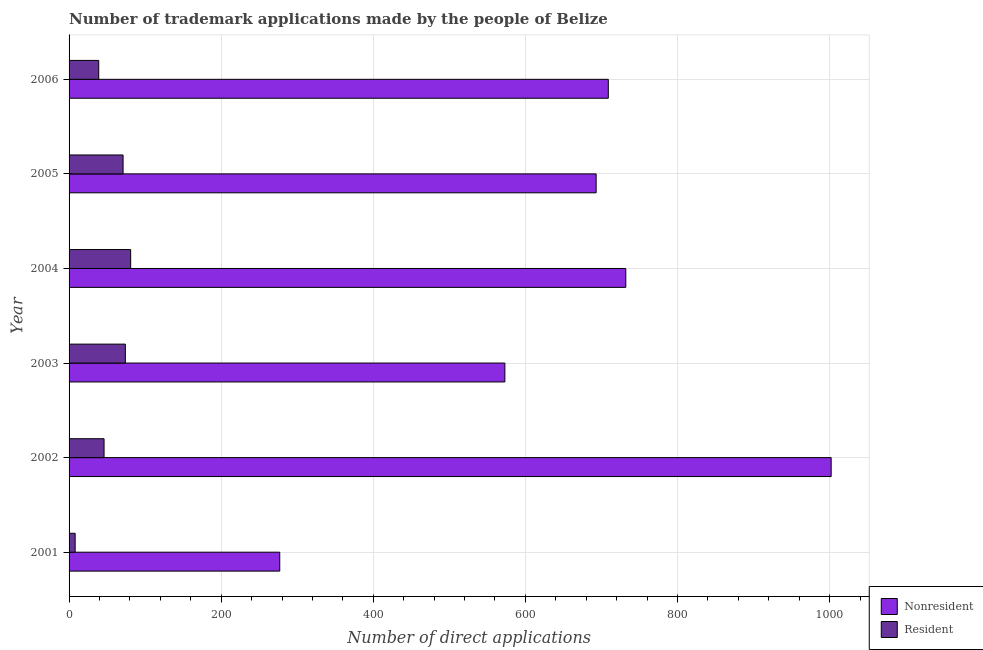How many different coloured bars are there?
Ensure brevity in your answer.  2. Are the number of bars per tick equal to the number of legend labels?
Provide a short and direct response. Yes. How many bars are there on the 1st tick from the bottom?
Your response must be concise. 2. What is the label of the 1st group of bars from the top?
Ensure brevity in your answer.  2006. What is the number of trademark applications made by residents in 2003?
Make the answer very short. 74. Across all years, what is the maximum number of trademark applications made by residents?
Offer a terse response. 81. Across all years, what is the minimum number of trademark applications made by non residents?
Make the answer very short. 277. In which year was the number of trademark applications made by residents minimum?
Keep it short and to the point. 2001. What is the total number of trademark applications made by non residents in the graph?
Ensure brevity in your answer.  3986. What is the difference between the number of trademark applications made by residents in 2003 and that in 2005?
Keep it short and to the point. 3. What is the difference between the number of trademark applications made by residents in 2006 and the number of trademark applications made by non residents in 2004?
Your response must be concise. -693. What is the average number of trademark applications made by residents per year?
Provide a short and direct response. 53.17. In the year 2006, what is the difference between the number of trademark applications made by non residents and number of trademark applications made by residents?
Your answer should be compact. 670. In how many years, is the number of trademark applications made by residents greater than 520 ?
Ensure brevity in your answer.  0. What is the ratio of the number of trademark applications made by residents in 2001 to that in 2002?
Offer a terse response. 0.17. What is the difference between the highest and the lowest number of trademark applications made by residents?
Your answer should be very brief. 73. Is the sum of the number of trademark applications made by residents in 2001 and 2004 greater than the maximum number of trademark applications made by non residents across all years?
Keep it short and to the point. No. What does the 2nd bar from the top in 2002 represents?
Make the answer very short. Nonresident. What does the 2nd bar from the bottom in 2001 represents?
Provide a short and direct response. Resident. How many bars are there?
Offer a terse response. 12. Are all the bars in the graph horizontal?
Give a very brief answer. Yes. Are the values on the major ticks of X-axis written in scientific E-notation?
Offer a very short reply. No. Where does the legend appear in the graph?
Keep it short and to the point. Bottom right. How many legend labels are there?
Your answer should be compact. 2. How are the legend labels stacked?
Your response must be concise. Vertical. What is the title of the graph?
Give a very brief answer. Number of trademark applications made by the people of Belize. What is the label or title of the X-axis?
Offer a very short reply. Number of direct applications. What is the label or title of the Y-axis?
Ensure brevity in your answer.  Year. What is the Number of direct applications in Nonresident in 2001?
Provide a succinct answer. 277. What is the Number of direct applications in Resident in 2001?
Your response must be concise. 8. What is the Number of direct applications in Nonresident in 2002?
Offer a terse response. 1002. What is the Number of direct applications of Nonresident in 2003?
Offer a terse response. 573. What is the Number of direct applications of Nonresident in 2004?
Your response must be concise. 732. What is the Number of direct applications in Nonresident in 2005?
Provide a short and direct response. 693. What is the Number of direct applications in Nonresident in 2006?
Your answer should be compact. 709. Across all years, what is the maximum Number of direct applications in Nonresident?
Offer a very short reply. 1002. Across all years, what is the maximum Number of direct applications in Resident?
Your response must be concise. 81. Across all years, what is the minimum Number of direct applications in Nonresident?
Offer a very short reply. 277. Across all years, what is the minimum Number of direct applications in Resident?
Your answer should be very brief. 8. What is the total Number of direct applications of Nonresident in the graph?
Keep it short and to the point. 3986. What is the total Number of direct applications in Resident in the graph?
Provide a short and direct response. 319. What is the difference between the Number of direct applications of Nonresident in 2001 and that in 2002?
Make the answer very short. -725. What is the difference between the Number of direct applications of Resident in 2001 and that in 2002?
Your response must be concise. -38. What is the difference between the Number of direct applications of Nonresident in 2001 and that in 2003?
Provide a succinct answer. -296. What is the difference between the Number of direct applications of Resident in 2001 and that in 2003?
Make the answer very short. -66. What is the difference between the Number of direct applications in Nonresident in 2001 and that in 2004?
Your answer should be compact. -455. What is the difference between the Number of direct applications of Resident in 2001 and that in 2004?
Give a very brief answer. -73. What is the difference between the Number of direct applications of Nonresident in 2001 and that in 2005?
Your response must be concise. -416. What is the difference between the Number of direct applications in Resident in 2001 and that in 2005?
Your answer should be compact. -63. What is the difference between the Number of direct applications in Nonresident in 2001 and that in 2006?
Provide a short and direct response. -432. What is the difference between the Number of direct applications in Resident in 2001 and that in 2006?
Keep it short and to the point. -31. What is the difference between the Number of direct applications of Nonresident in 2002 and that in 2003?
Your answer should be compact. 429. What is the difference between the Number of direct applications of Resident in 2002 and that in 2003?
Offer a very short reply. -28. What is the difference between the Number of direct applications of Nonresident in 2002 and that in 2004?
Make the answer very short. 270. What is the difference between the Number of direct applications of Resident in 2002 and that in 2004?
Provide a succinct answer. -35. What is the difference between the Number of direct applications of Nonresident in 2002 and that in 2005?
Offer a very short reply. 309. What is the difference between the Number of direct applications in Resident in 2002 and that in 2005?
Your response must be concise. -25. What is the difference between the Number of direct applications in Nonresident in 2002 and that in 2006?
Provide a succinct answer. 293. What is the difference between the Number of direct applications in Nonresident in 2003 and that in 2004?
Offer a very short reply. -159. What is the difference between the Number of direct applications in Resident in 2003 and that in 2004?
Ensure brevity in your answer.  -7. What is the difference between the Number of direct applications of Nonresident in 2003 and that in 2005?
Provide a succinct answer. -120. What is the difference between the Number of direct applications in Nonresident in 2003 and that in 2006?
Ensure brevity in your answer.  -136. What is the difference between the Number of direct applications of Resident in 2003 and that in 2006?
Your answer should be compact. 35. What is the difference between the Number of direct applications of Resident in 2004 and that in 2005?
Provide a succinct answer. 10. What is the difference between the Number of direct applications in Nonresident in 2004 and that in 2006?
Your answer should be very brief. 23. What is the difference between the Number of direct applications of Nonresident in 2005 and that in 2006?
Give a very brief answer. -16. What is the difference between the Number of direct applications of Resident in 2005 and that in 2006?
Offer a terse response. 32. What is the difference between the Number of direct applications of Nonresident in 2001 and the Number of direct applications of Resident in 2002?
Ensure brevity in your answer.  231. What is the difference between the Number of direct applications in Nonresident in 2001 and the Number of direct applications in Resident in 2003?
Your answer should be very brief. 203. What is the difference between the Number of direct applications in Nonresident in 2001 and the Number of direct applications in Resident in 2004?
Keep it short and to the point. 196. What is the difference between the Number of direct applications of Nonresident in 2001 and the Number of direct applications of Resident in 2005?
Offer a terse response. 206. What is the difference between the Number of direct applications in Nonresident in 2001 and the Number of direct applications in Resident in 2006?
Ensure brevity in your answer.  238. What is the difference between the Number of direct applications of Nonresident in 2002 and the Number of direct applications of Resident in 2003?
Offer a very short reply. 928. What is the difference between the Number of direct applications of Nonresident in 2002 and the Number of direct applications of Resident in 2004?
Keep it short and to the point. 921. What is the difference between the Number of direct applications of Nonresident in 2002 and the Number of direct applications of Resident in 2005?
Your answer should be compact. 931. What is the difference between the Number of direct applications in Nonresident in 2002 and the Number of direct applications in Resident in 2006?
Your answer should be compact. 963. What is the difference between the Number of direct applications of Nonresident in 2003 and the Number of direct applications of Resident in 2004?
Provide a short and direct response. 492. What is the difference between the Number of direct applications of Nonresident in 2003 and the Number of direct applications of Resident in 2005?
Offer a terse response. 502. What is the difference between the Number of direct applications of Nonresident in 2003 and the Number of direct applications of Resident in 2006?
Ensure brevity in your answer.  534. What is the difference between the Number of direct applications of Nonresident in 2004 and the Number of direct applications of Resident in 2005?
Your response must be concise. 661. What is the difference between the Number of direct applications in Nonresident in 2004 and the Number of direct applications in Resident in 2006?
Ensure brevity in your answer.  693. What is the difference between the Number of direct applications in Nonresident in 2005 and the Number of direct applications in Resident in 2006?
Your answer should be compact. 654. What is the average Number of direct applications in Nonresident per year?
Give a very brief answer. 664.33. What is the average Number of direct applications of Resident per year?
Your answer should be very brief. 53.17. In the year 2001, what is the difference between the Number of direct applications in Nonresident and Number of direct applications in Resident?
Make the answer very short. 269. In the year 2002, what is the difference between the Number of direct applications in Nonresident and Number of direct applications in Resident?
Your answer should be very brief. 956. In the year 2003, what is the difference between the Number of direct applications in Nonresident and Number of direct applications in Resident?
Offer a terse response. 499. In the year 2004, what is the difference between the Number of direct applications of Nonresident and Number of direct applications of Resident?
Make the answer very short. 651. In the year 2005, what is the difference between the Number of direct applications in Nonresident and Number of direct applications in Resident?
Your answer should be compact. 622. In the year 2006, what is the difference between the Number of direct applications in Nonresident and Number of direct applications in Resident?
Make the answer very short. 670. What is the ratio of the Number of direct applications of Nonresident in 2001 to that in 2002?
Offer a terse response. 0.28. What is the ratio of the Number of direct applications of Resident in 2001 to that in 2002?
Your answer should be compact. 0.17. What is the ratio of the Number of direct applications in Nonresident in 2001 to that in 2003?
Provide a short and direct response. 0.48. What is the ratio of the Number of direct applications of Resident in 2001 to that in 2003?
Make the answer very short. 0.11. What is the ratio of the Number of direct applications of Nonresident in 2001 to that in 2004?
Your answer should be compact. 0.38. What is the ratio of the Number of direct applications of Resident in 2001 to that in 2004?
Offer a very short reply. 0.1. What is the ratio of the Number of direct applications of Nonresident in 2001 to that in 2005?
Give a very brief answer. 0.4. What is the ratio of the Number of direct applications in Resident in 2001 to that in 2005?
Offer a very short reply. 0.11. What is the ratio of the Number of direct applications in Nonresident in 2001 to that in 2006?
Provide a succinct answer. 0.39. What is the ratio of the Number of direct applications of Resident in 2001 to that in 2006?
Give a very brief answer. 0.21. What is the ratio of the Number of direct applications in Nonresident in 2002 to that in 2003?
Your answer should be compact. 1.75. What is the ratio of the Number of direct applications of Resident in 2002 to that in 2003?
Provide a short and direct response. 0.62. What is the ratio of the Number of direct applications of Nonresident in 2002 to that in 2004?
Provide a short and direct response. 1.37. What is the ratio of the Number of direct applications in Resident in 2002 to that in 2004?
Your response must be concise. 0.57. What is the ratio of the Number of direct applications in Nonresident in 2002 to that in 2005?
Give a very brief answer. 1.45. What is the ratio of the Number of direct applications of Resident in 2002 to that in 2005?
Provide a succinct answer. 0.65. What is the ratio of the Number of direct applications of Nonresident in 2002 to that in 2006?
Your answer should be compact. 1.41. What is the ratio of the Number of direct applications in Resident in 2002 to that in 2006?
Offer a terse response. 1.18. What is the ratio of the Number of direct applications in Nonresident in 2003 to that in 2004?
Provide a succinct answer. 0.78. What is the ratio of the Number of direct applications of Resident in 2003 to that in 2004?
Make the answer very short. 0.91. What is the ratio of the Number of direct applications in Nonresident in 2003 to that in 2005?
Your response must be concise. 0.83. What is the ratio of the Number of direct applications in Resident in 2003 to that in 2005?
Offer a very short reply. 1.04. What is the ratio of the Number of direct applications in Nonresident in 2003 to that in 2006?
Provide a succinct answer. 0.81. What is the ratio of the Number of direct applications in Resident in 2003 to that in 2006?
Provide a succinct answer. 1.9. What is the ratio of the Number of direct applications of Nonresident in 2004 to that in 2005?
Keep it short and to the point. 1.06. What is the ratio of the Number of direct applications in Resident in 2004 to that in 2005?
Ensure brevity in your answer.  1.14. What is the ratio of the Number of direct applications in Nonresident in 2004 to that in 2006?
Offer a very short reply. 1.03. What is the ratio of the Number of direct applications in Resident in 2004 to that in 2006?
Ensure brevity in your answer.  2.08. What is the ratio of the Number of direct applications in Nonresident in 2005 to that in 2006?
Provide a short and direct response. 0.98. What is the ratio of the Number of direct applications of Resident in 2005 to that in 2006?
Your answer should be very brief. 1.82. What is the difference between the highest and the second highest Number of direct applications of Nonresident?
Your answer should be very brief. 270. What is the difference between the highest and the second highest Number of direct applications in Resident?
Provide a short and direct response. 7. What is the difference between the highest and the lowest Number of direct applications of Nonresident?
Offer a very short reply. 725. What is the difference between the highest and the lowest Number of direct applications in Resident?
Ensure brevity in your answer.  73. 